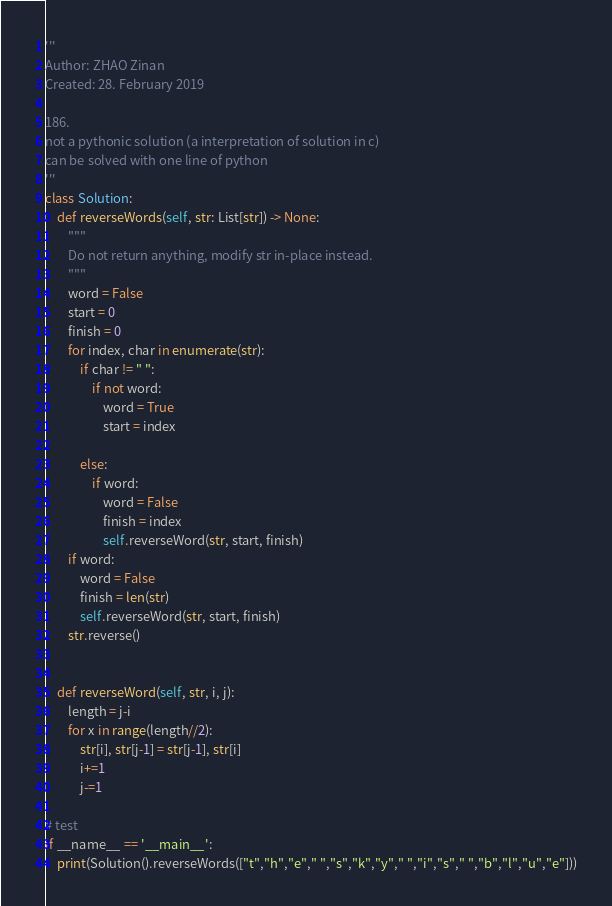<code> <loc_0><loc_0><loc_500><loc_500><_Python_>'''
Author: ZHAO Zinan
Created: 28. February 2019

186. 
not a pythonic solution (a interpretation of solution in c)
can be solved with one line of python 
''' 
class Solution:
    def reverseWords(self, str: List[str]) -> None:
        """
        Do not return anything, modify str in-place instead.
        """
        word = False
        start = 0
        finish = 0
        for index, char in enumerate(str):
            if char != " ":
                if not word:
                    word = True
                    start = index
                
            else:
                if word:
                    word = False
                    finish = index
                    self.reverseWord(str, start, finish)
        if word:
            word = False
            finish = len(str)
            self.reverseWord(str, start, finish)
        str.reverse()

        
    def reverseWord(self, str, i, j):
        length = j-i
        for x in range(length//2):
            str[i], str[j-1] = str[j-1], str[i]
            i+=1
            j-=1
        
# test
if __name__ == '__main__':
    print(Solution().reverseWords(["t","h","e"," ","s","k","y"," ","i","s"," ","b","l","u","e"]))</code> 